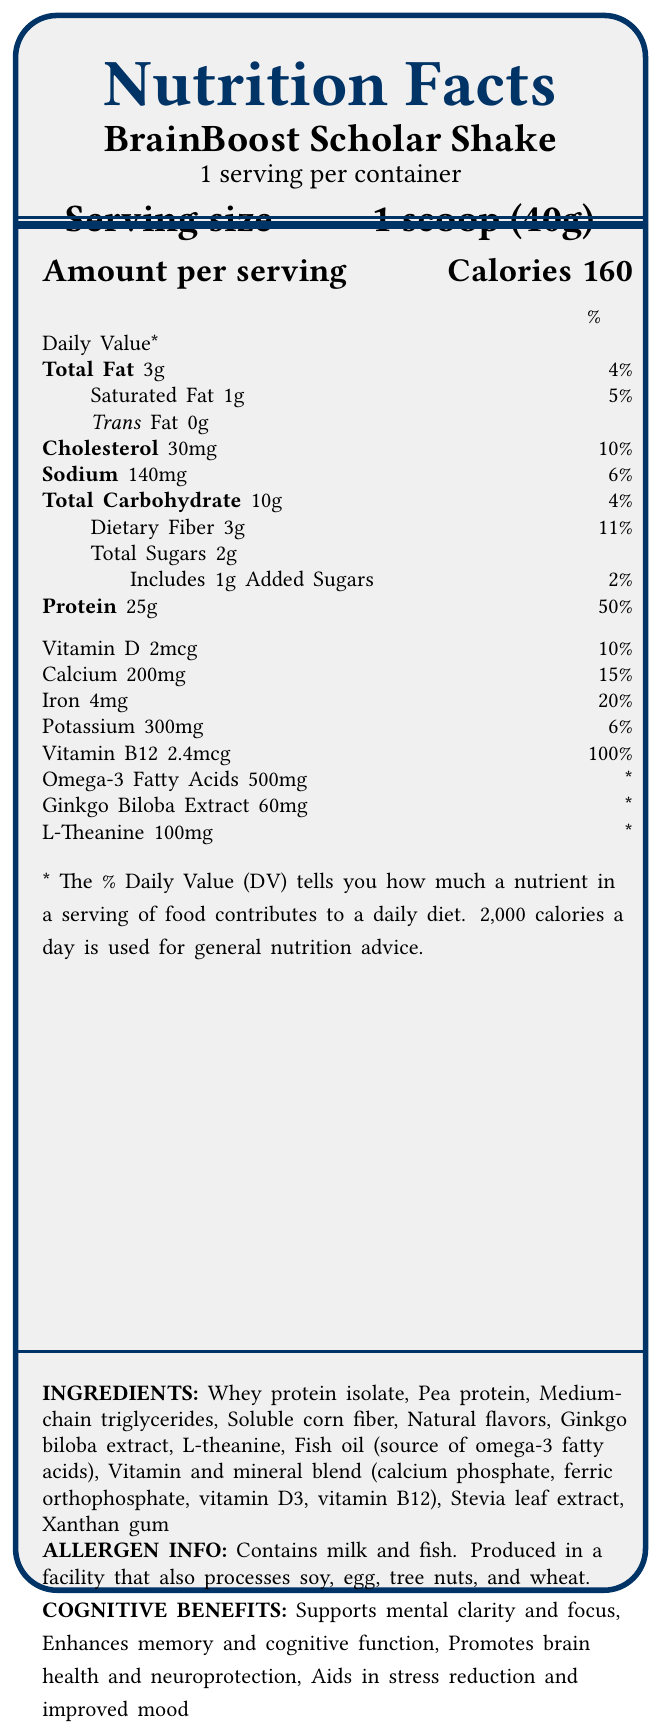what is the serving size of the BrainBoost Scholar Shake? The serving size is explicitly mentioned as "1 scoop (40g)" in the document.
Answer: 1 scoop (40g) how many calories are in one serving? The document states that each serving contains 160 calories.
Answer: 160 how much protein does one serving contain, and what percentage of the daily value does this represent? The document lists 25g of protein per serving, which represents 50% of the daily value.
Answer: 25g, 50% what are the two primary sources of protein in the product? The ingredients list mentions "Whey protein isolate" and "Pea protein" as the primary sources of protein.
Answer: Whey protein isolate and Pea protein what are the cognitive benefits advertised for the BrainBoost Scholar Shake? The cognitive benefits are listed in the document.
Answer: Supports mental clarity and focus, Enhances memory and cognitive function, Promotes brain health and neuroprotection, Aids in stress reduction and improved mood how much total fat does one serving contain? The document states that each serving contains 3g of total fat.
Answer: 3g what is the amount of dietary fiber in one serving? The document lists 3g of dietary fiber per serving.
Answer: 3g which of the following is NOT an ingredient in the BrainBoost Scholar Shake? A. Soy protein B. Fish oil C. Xanthan gum D. L-theanine Soy protein is not listed among the ingredients, but Fish oil, Xanthan gum, and L-theanine are.
Answer: A. Soy protein what is the percentage of daily value for sodium provided by one serving? A. 4% B. 6% C. 10% D. 15% The document states that one serving provides 6% of the daily value for sodium.
Answer: B. 6% is the product designed to support cognitive endurance for extended periods of academic writing and peer review? The academic-specific features of the product include supporting cognitive endurance for extended academic tasks.
Answer: Yes summarize the main purpose and benefits of the BrainBoost Scholar Shake based on the document. The document describes the product's nutritional details, cognitive benefits, ingredients, and its suitability for academics.
Answer: The BrainBoost Scholar Shake is a high-protein meal replacement designed for busy academics. It aims to support cognitive benefits such as mental clarity, memory enhancement, brain health, and stress reduction. The shake is convenient and provides a balanced nutrient profile to assist with sustained mental energy and cognitive endurance during demanding academic tasks. what are some of the vitamins and minerals included in the product’s blend? The vitamin and mineral blend includes vitamin D3, calcium phosphate, ferric orthophosphate, and vitamin B12.
Answer: Vitamin D3, calcium phosphate, ferric orthophosphate, vitamin B12 what is the recommended preparation method for the BrainBoost Scholar Shake? The preparation instructions specify mixing 1 scoop with cold water or preferred milk, shaking well, and consuming within a specific timeframe.
Answer: Mix 1 scoop (40g) with 8-10 oz of cold water or preferred milk, shake well, and consume within 20 minutes before or after mental tasks. how much ginkgo biloba extract is in one serving, and what's its daily value percentage? One serving contains 60mg of ginkgo biloba extract, but the daily value percentage is not specified (marked as *).
Answer: 60mg, * (not specified) are there any sugars added to the BrainBoost Scholar Shake, and if so, how much? The document mentions that the product includes 1g of added sugars.
Answer: Yes, 1g is the exact percentage daily value of omega-3 fatty acids provided in the document? The daily value percentage for omega-3 fatty acids is not provided; it is marked with an asterisk (*).
Answer: No how many servings are there in one container of BrainBoost Scholar Shake? The document states that there are 15 servings per container.
Answer: 15 what are the allergen warnings associated with this product? The allergen information is clearly listed in the document.
Answer: Contains milk and fish. Produced in a facility that also processes soy, egg, tree nuts, and wheat. can the exact cognitive benefits be determined from the percentage daily values provided for ginkgo biloba extract? The cognitive benefits based on the percentage daily values for ginkgo biloba extract cannot be determined as the daily value is not specified.
Answer: No 